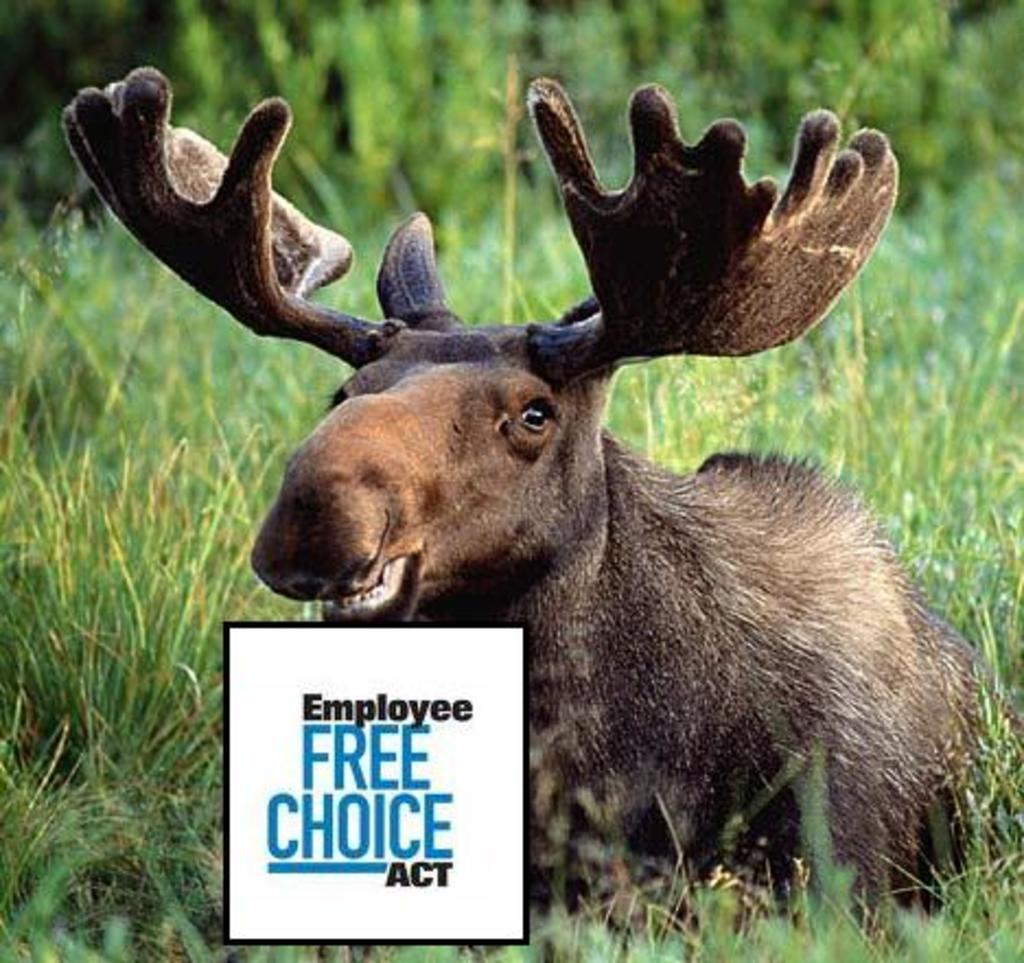What type of animal is on the ground in the image? The specific type of animal cannot be determined from the provided facts. What can be seen in the background of the image? There are trees and grass in the image. Is there any text present in the image? Yes, there is text in the image. What event is the woman starting in the image? There is no woman present in the image, so it is not possible to answer that question. 